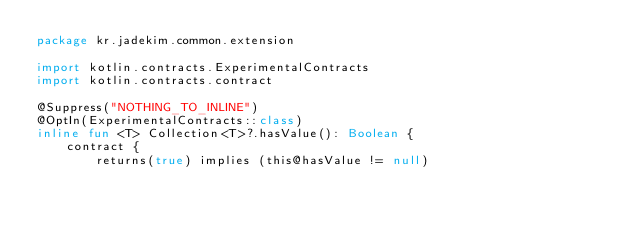Convert code to text. <code><loc_0><loc_0><loc_500><loc_500><_Kotlin_>package kr.jadekim.common.extension

import kotlin.contracts.ExperimentalContracts
import kotlin.contracts.contract

@Suppress("NOTHING_TO_INLINE")
@OptIn(ExperimentalContracts::class)
inline fun <T> Collection<T>?.hasValue(): Boolean {
    contract {
        returns(true) implies (this@hasValue != null)</code> 